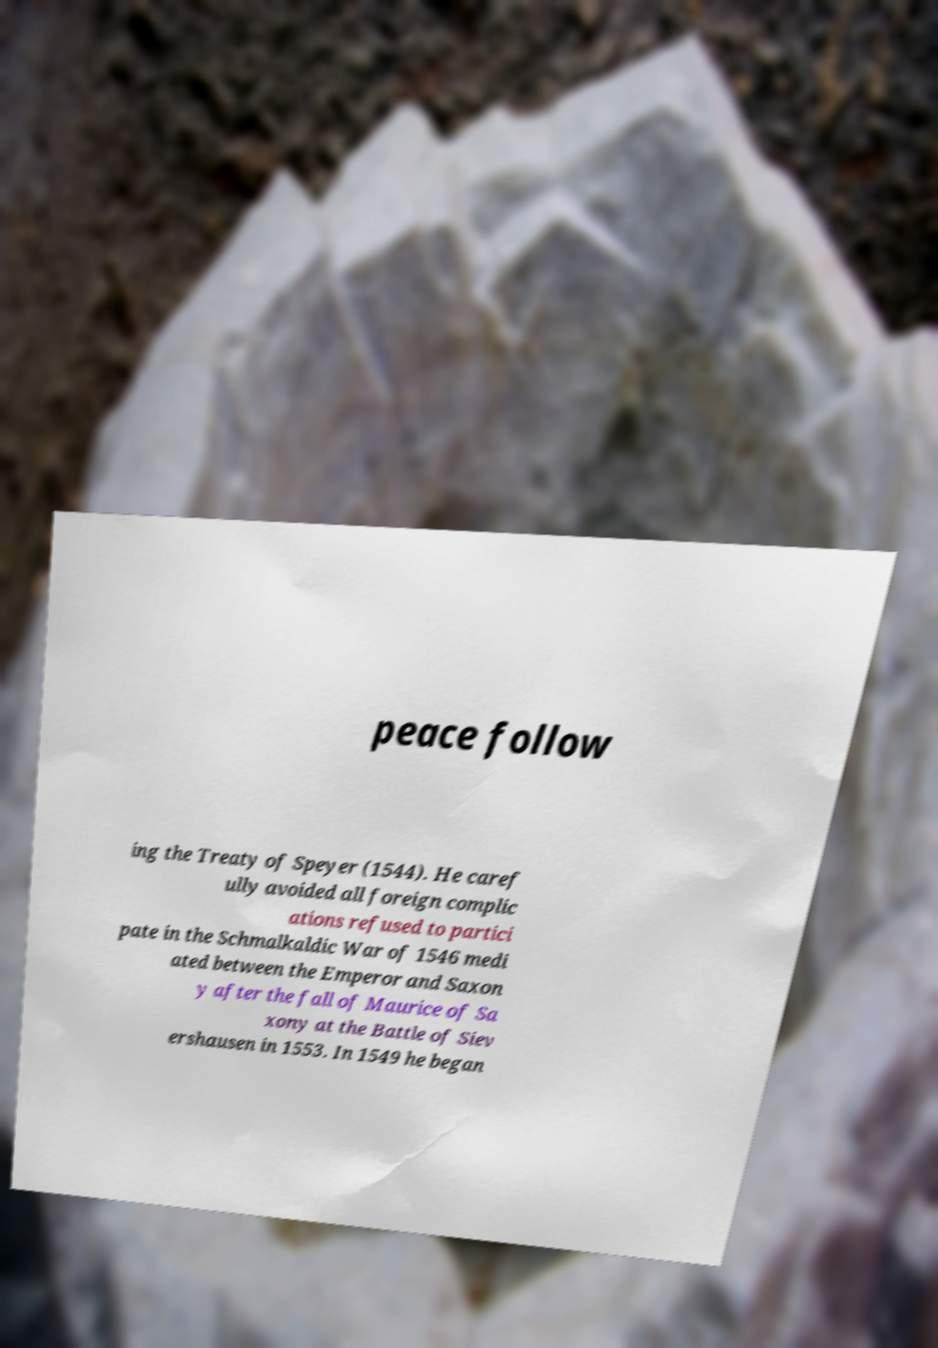Could you extract and type out the text from this image? peace follow ing the Treaty of Speyer (1544). He caref ully avoided all foreign complic ations refused to partici pate in the Schmalkaldic War of 1546 medi ated between the Emperor and Saxon y after the fall of Maurice of Sa xony at the Battle of Siev ershausen in 1553. In 1549 he began 